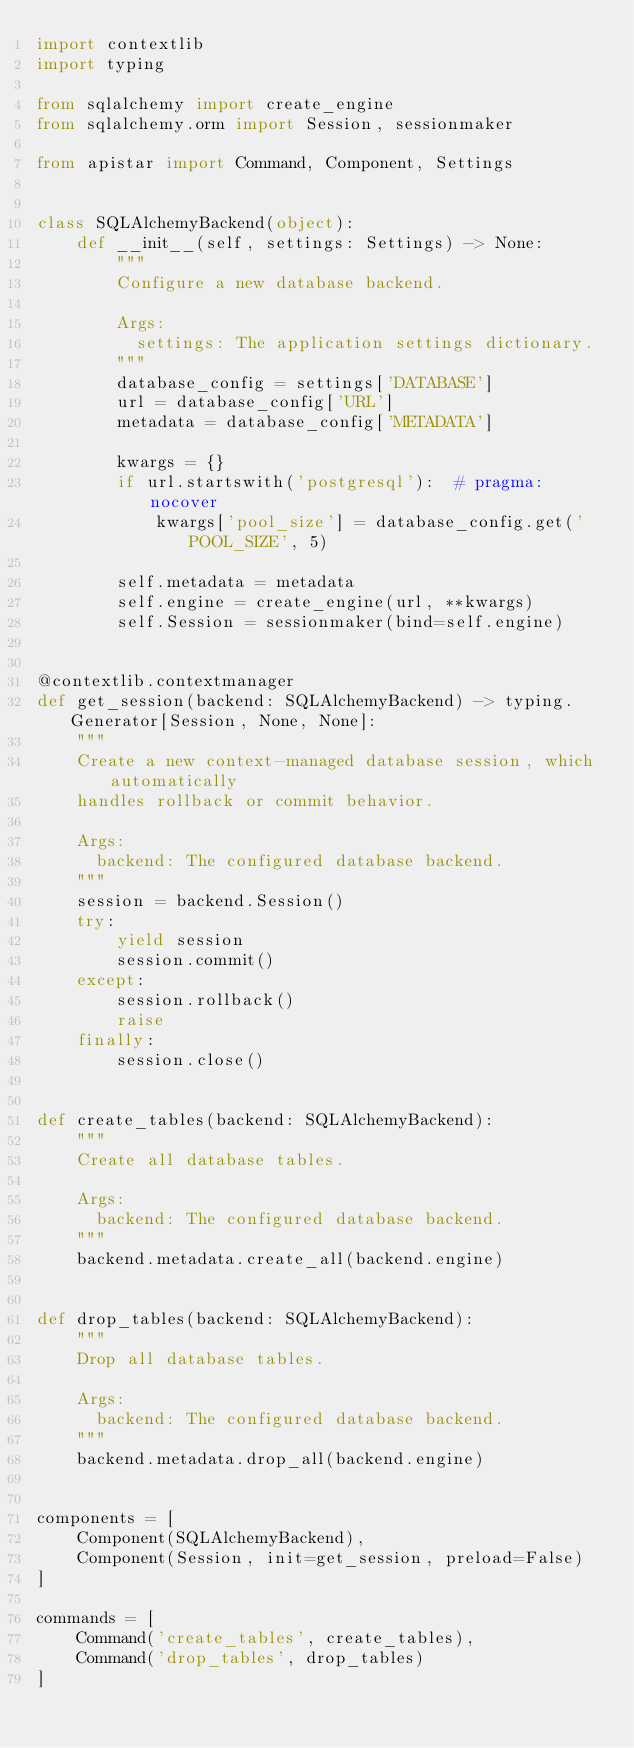Convert code to text. <code><loc_0><loc_0><loc_500><loc_500><_Python_>import contextlib
import typing

from sqlalchemy import create_engine
from sqlalchemy.orm import Session, sessionmaker

from apistar import Command, Component, Settings


class SQLAlchemyBackend(object):
    def __init__(self, settings: Settings) -> None:
        """
        Configure a new database backend.

        Args:
          settings: The application settings dictionary.
        """
        database_config = settings['DATABASE']
        url = database_config['URL']
        metadata = database_config['METADATA']

        kwargs = {}
        if url.startswith('postgresql'):  # pragma: nocover
            kwargs['pool_size'] = database_config.get('POOL_SIZE', 5)

        self.metadata = metadata
        self.engine = create_engine(url, **kwargs)
        self.Session = sessionmaker(bind=self.engine)


@contextlib.contextmanager
def get_session(backend: SQLAlchemyBackend) -> typing.Generator[Session, None, None]:
    """
    Create a new context-managed database session, which automatically
    handles rollback or commit behavior.

    Args:
      backend: The configured database backend.
    """
    session = backend.Session()
    try:
        yield session
        session.commit()
    except:
        session.rollback()
        raise
    finally:
        session.close()


def create_tables(backend: SQLAlchemyBackend):
    """
    Create all database tables.

    Args:
      backend: The configured database backend.
    """
    backend.metadata.create_all(backend.engine)


def drop_tables(backend: SQLAlchemyBackend):
    """
    Drop all database tables.

    Args:
      backend: The configured database backend.
    """
    backend.metadata.drop_all(backend.engine)


components = [
    Component(SQLAlchemyBackend),
    Component(Session, init=get_session, preload=False)
]

commands = [
    Command('create_tables', create_tables),
    Command('drop_tables', drop_tables)
]
</code> 